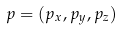Convert formula to latex. <formula><loc_0><loc_0><loc_500><loc_500>p = ( p _ { x } , p _ { y } , p _ { z } )</formula> 